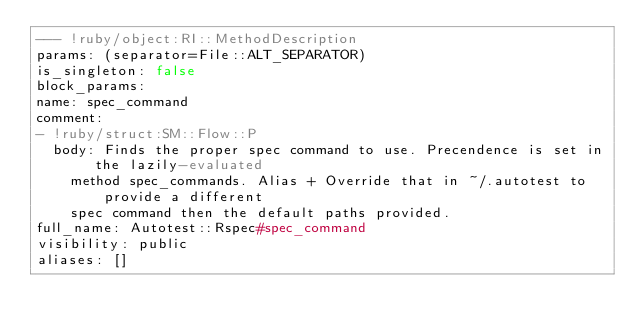Convert code to text. <code><loc_0><loc_0><loc_500><loc_500><_YAML_>--- !ruby/object:RI::MethodDescription
params: (separator=File::ALT_SEPARATOR)
is_singleton: false
block_params: 
name: spec_command
comment: 
- !ruby/struct:SM::Flow::P
  body: Finds the proper spec command to use. Precendence is set in the lazily-evaluated
    method spec_commands. Alias + Override that in ~/.autotest to provide a different
    spec command then the default paths provided.
full_name: Autotest::Rspec#spec_command
visibility: public
aliases: []
</code> 